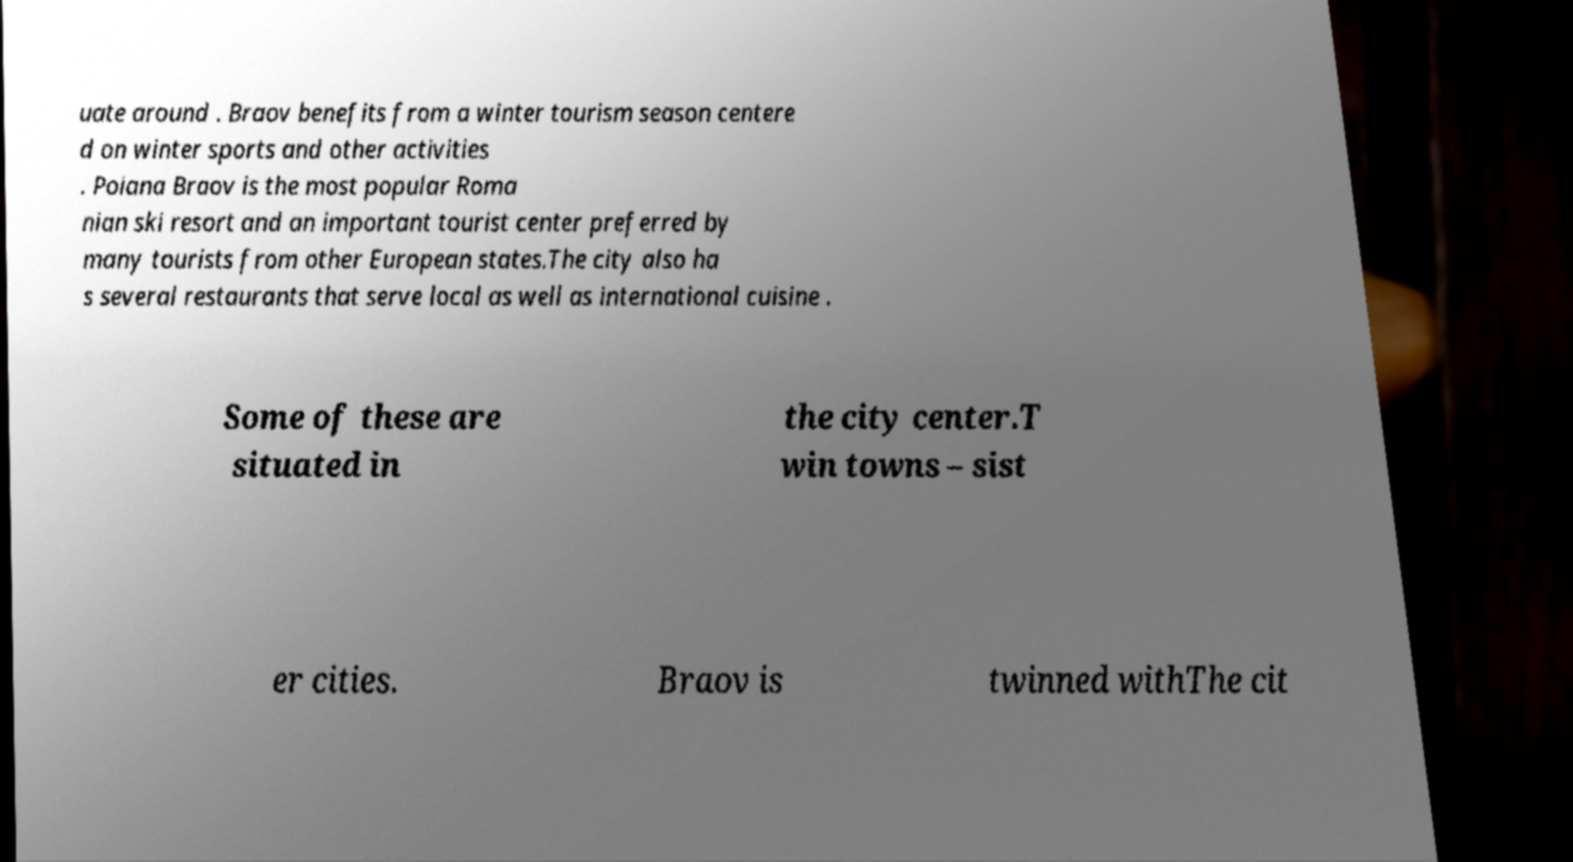Can you accurately transcribe the text from the provided image for me? uate around . Braov benefits from a winter tourism season centere d on winter sports and other activities . Poiana Braov is the most popular Roma nian ski resort and an important tourist center preferred by many tourists from other European states.The city also ha s several restaurants that serve local as well as international cuisine . Some of these are situated in the city center.T win towns – sist er cities. Braov is twinned withThe cit 